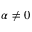<formula> <loc_0><loc_0><loc_500><loc_500>\alpha \neq 0</formula> 